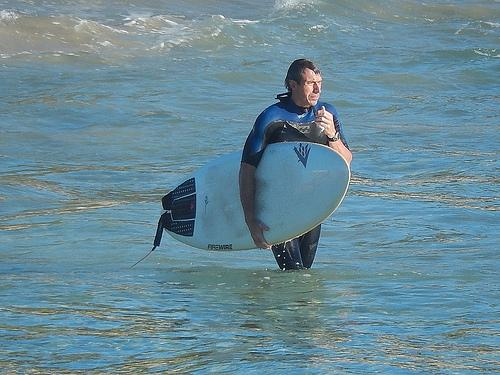What is the primary activity taking place in the image? A man is holding a surfboard and wading in the water. Use complex reasoning to deduce the man's probable actions after the captured moment in the image. The man is likely to get on his surfboard and start surfing when he spots a suitable wave. Examine the quality of the image by mentioning any noticeable issues. The image appears to have clear details and a good quality, with no significant issues detected. Comment on the appearance and state of the sea in the image. The sea has calm blue waters with white and gray ocean waves scattered around. Identify the color of the wetsuit the man is wearing and the color of the surfboard. The man is wearing a blue and black wetsuit and holds a white surfboard. Assess the interaction between the man and the surfboard in the image. The man is holding the surfboard with one hand, and the surfboard has a cord attached to it. Describe the person in the image, including their clothing and any accessories. The man is wearing a water suit, a wrist watch, and holding a surfboard while wading in the water. Describe the emotions or mood conveyed by the image. The image conveys a sense of adventure, relaxation, and connection to nature. Estimate the number of ocean waves present in the image. There are around nine instances of white and gray ocean waves in the image. In the picture, what are some details that suggest the man's position? The man is in the water, holding a surfboard, and looking towards the sun. Multiple choice: What type of waves are seen in the water? a) large, intimidating waves b) small, choppy waves c) calm, rolling waves b) small, choppy waves What is the color and type of the wetsuit worn by the man? Blue and black Can you see waves in the water? How would you describe them? Yes, white and gray ocean waves Identify the color of the waters in the sea. Blue By wearing a wetsuit, what activity is the man likely prepared for? Surfing What is happening in the image that implies calm waters? Calm waters in the sea What type of wrist accessory is the man wearing? A watch What type of body of water is the man in? Ocean Which part of the surfboard has a visible cord? The top part What is the man doing with the surfboard in the water? He is holding it Is there a distinct color difference between the water and the sky in the image? No What is the primary object that the man is holding? A white surfboard Describe the man's position in the water. Wading in the water What does the presence of the cord on the surfboard indicate? It is used to connect the surfboard to the surfer's leg Explain the weather in the image. Sunny Choose the correct description of the image: a) A man swimming in a pool, b) A surfer holding a white surfboard in the water c) A man riding a skateboard b) A surfer holding a white surfboard in the water What type of surfboard is the man holding, and what color is it? White surfboard 